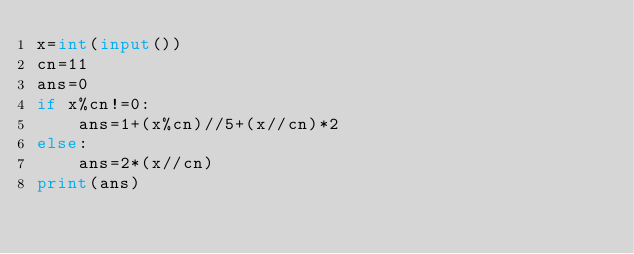Convert code to text. <code><loc_0><loc_0><loc_500><loc_500><_Python_>x=int(input())
cn=11
ans=0
if x%cn!=0:
    ans=1+(x%cn)//5+(x//cn)*2
else:
    ans=2*(x//cn)
print(ans)</code> 